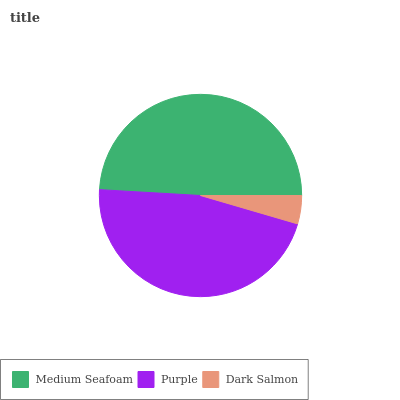Is Dark Salmon the minimum?
Answer yes or no. Yes. Is Medium Seafoam the maximum?
Answer yes or no. Yes. Is Purple the minimum?
Answer yes or no. No. Is Purple the maximum?
Answer yes or no. No. Is Medium Seafoam greater than Purple?
Answer yes or no. Yes. Is Purple less than Medium Seafoam?
Answer yes or no. Yes. Is Purple greater than Medium Seafoam?
Answer yes or no. No. Is Medium Seafoam less than Purple?
Answer yes or no. No. Is Purple the high median?
Answer yes or no. Yes. Is Purple the low median?
Answer yes or no. Yes. Is Dark Salmon the high median?
Answer yes or no. No. Is Medium Seafoam the low median?
Answer yes or no. No. 